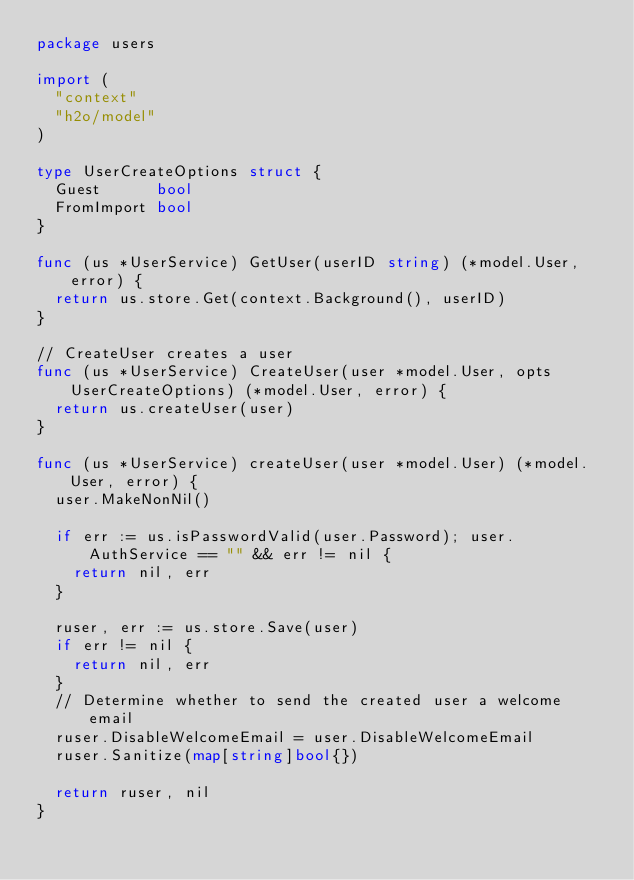Convert code to text. <code><loc_0><loc_0><loc_500><loc_500><_Go_>package users

import (
	"context"
	"h2o/model"
)

type UserCreateOptions struct {
	Guest      bool
	FromImport bool
}

func (us *UserService) GetUser(userID string) (*model.User, error) {
	return us.store.Get(context.Background(), userID)
}

// CreateUser creates a user
func (us *UserService) CreateUser(user *model.User, opts UserCreateOptions) (*model.User, error) {
	return us.createUser(user)
}

func (us *UserService) createUser(user *model.User) (*model.User, error) {
	user.MakeNonNil()

	if err := us.isPasswordValid(user.Password); user.AuthService == "" && err != nil {
		return nil, err
	}

	ruser, err := us.store.Save(user)
	if err != nil {
		return nil, err
	}
	// Determine whether to send the created user a welcome email
	ruser.DisableWelcomeEmail = user.DisableWelcomeEmail
	ruser.Sanitize(map[string]bool{})

	return ruser, nil
}
</code> 